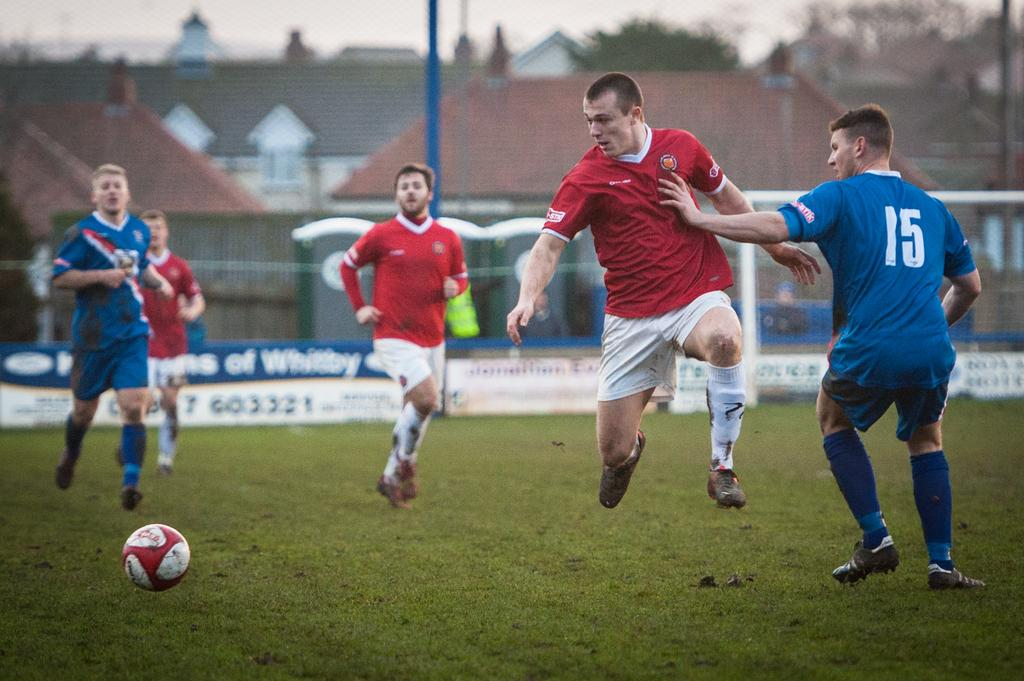<image>
Create a compact narrative representing the image presented. some players with one that has 15 on them 